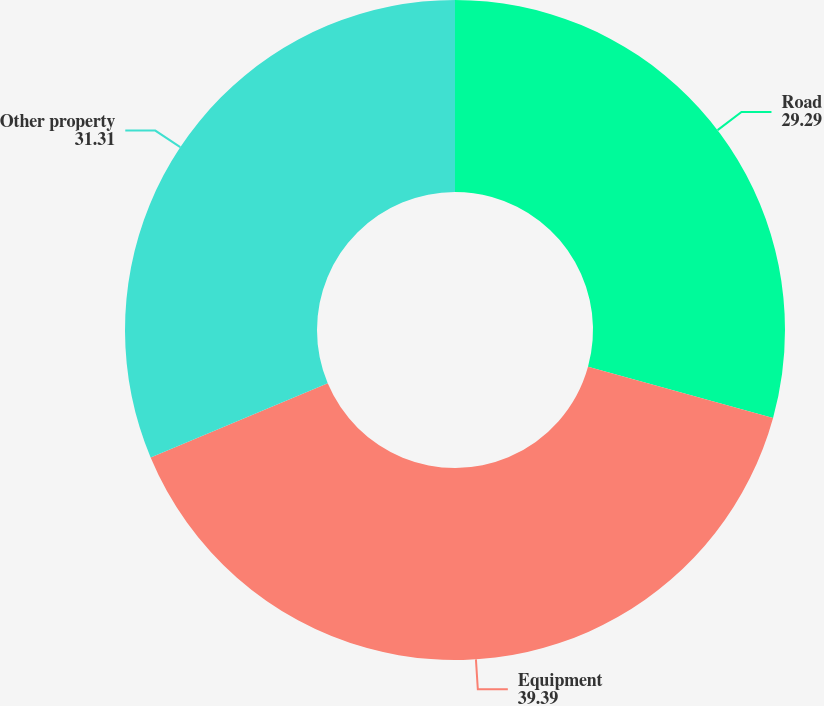Convert chart to OTSL. <chart><loc_0><loc_0><loc_500><loc_500><pie_chart><fcel>Road<fcel>Equipment<fcel>Other property<nl><fcel>29.29%<fcel>39.39%<fcel>31.31%<nl></chart> 